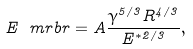Convert formula to latex. <formula><loc_0><loc_0><loc_500><loc_500>E _ { \ } m r { b r } = A \frac { \gamma ^ { 5 / 3 } R ^ { 4 / 3 } } { E ^ { \ast 2 / 3 } } , \label H { e q \colon g e n e r i c - c r i t i c a l - e n e r g y }</formula> 